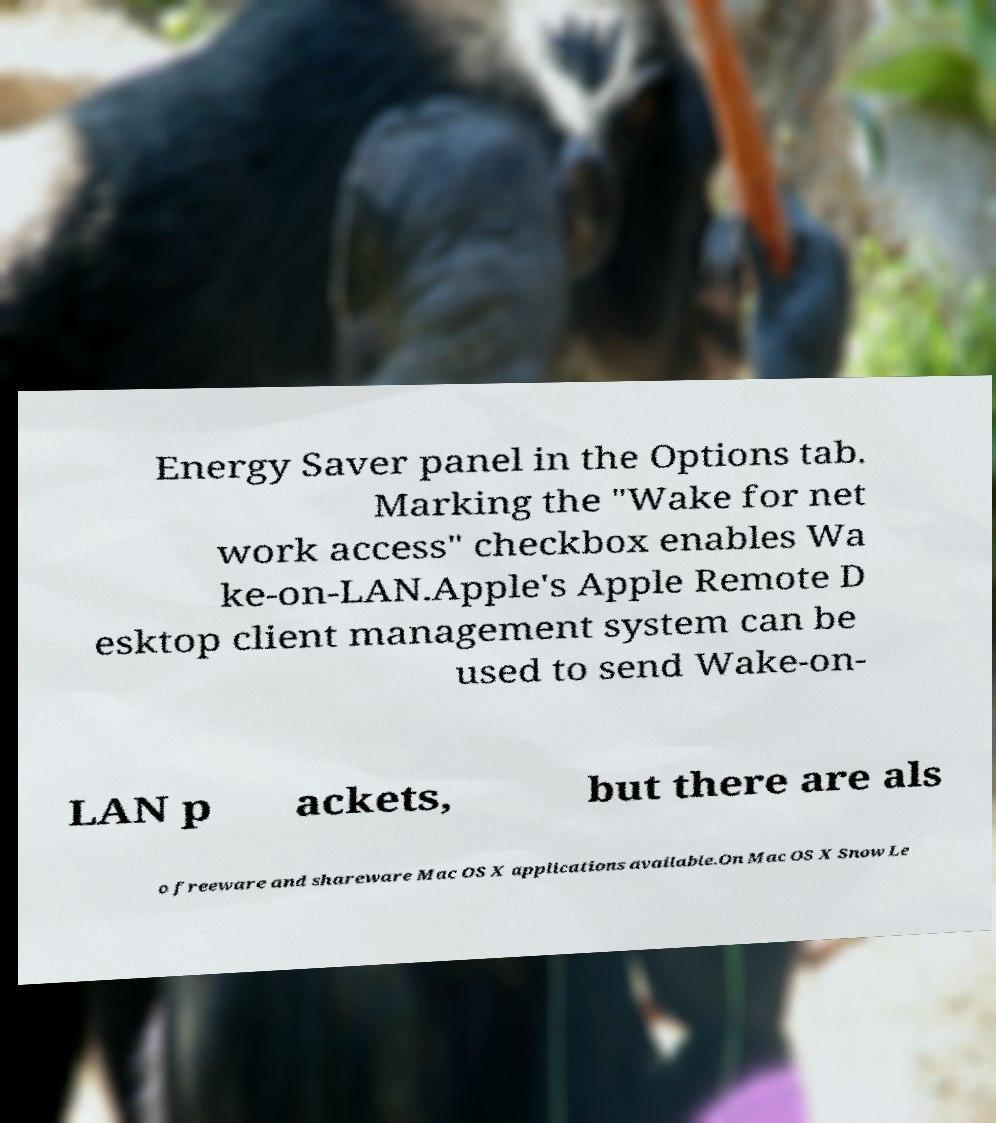Please identify and transcribe the text found in this image. Energy Saver panel in the Options tab. Marking the "Wake for net work access" checkbox enables Wa ke-on-LAN.Apple's Apple Remote D esktop client management system can be used to send Wake-on- LAN p ackets, but there are als o freeware and shareware Mac OS X applications available.On Mac OS X Snow Le 